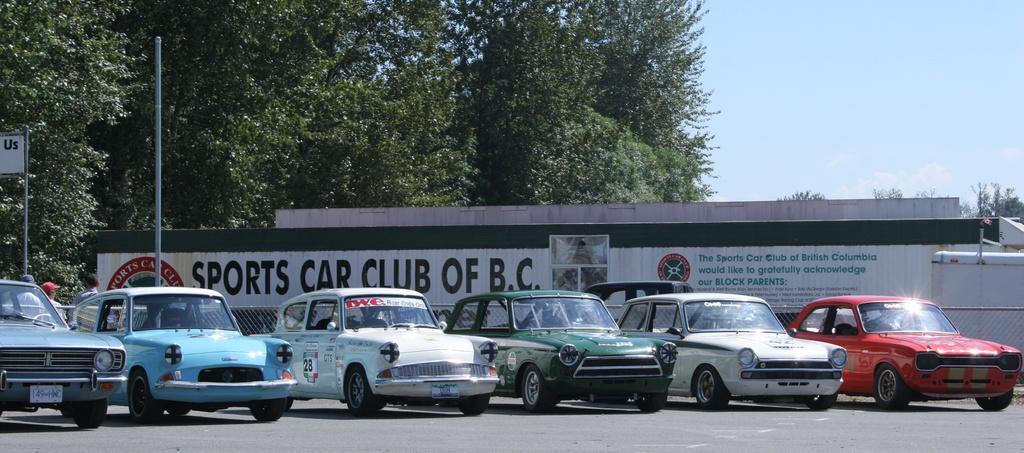Could you give a brief overview of what you see in this image? In the picture we can see some vintage cars are parked on the path, behind it, we can see a pole and a board to the wall written on it as sports car club of B. C., in the background we can see trees and sky. 